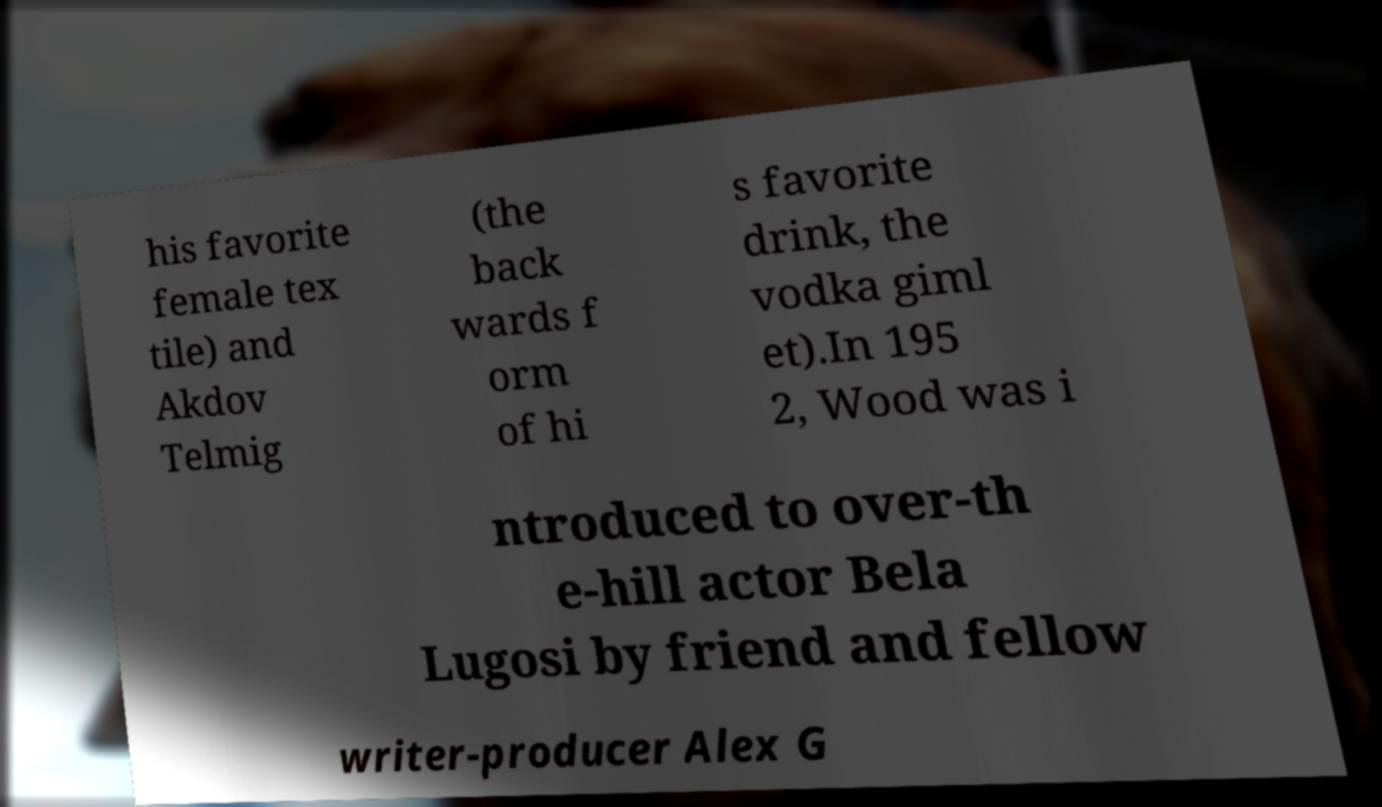Could you assist in decoding the text presented in this image and type it out clearly? his favorite female tex tile) and Akdov Telmig (the back wards f orm of hi s favorite drink, the vodka giml et).In 195 2, Wood was i ntroduced to over-th e-hill actor Bela Lugosi by friend and fellow writer-producer Alex G 